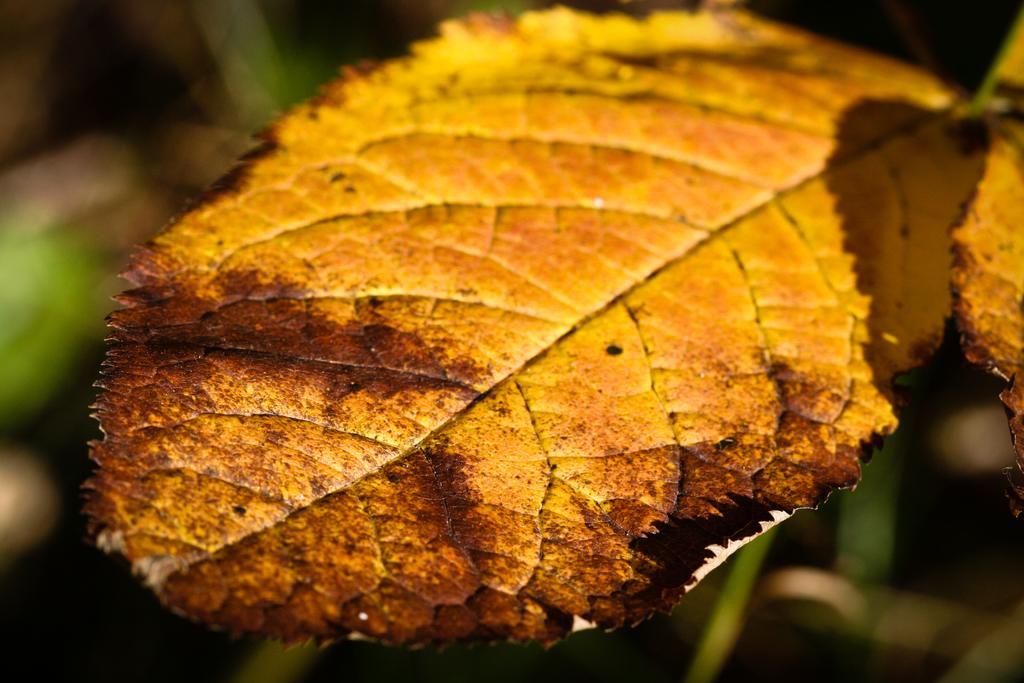Could you give a brief overview of what you see in this image? In this picture we can see a few leaves. Background is blurry. 